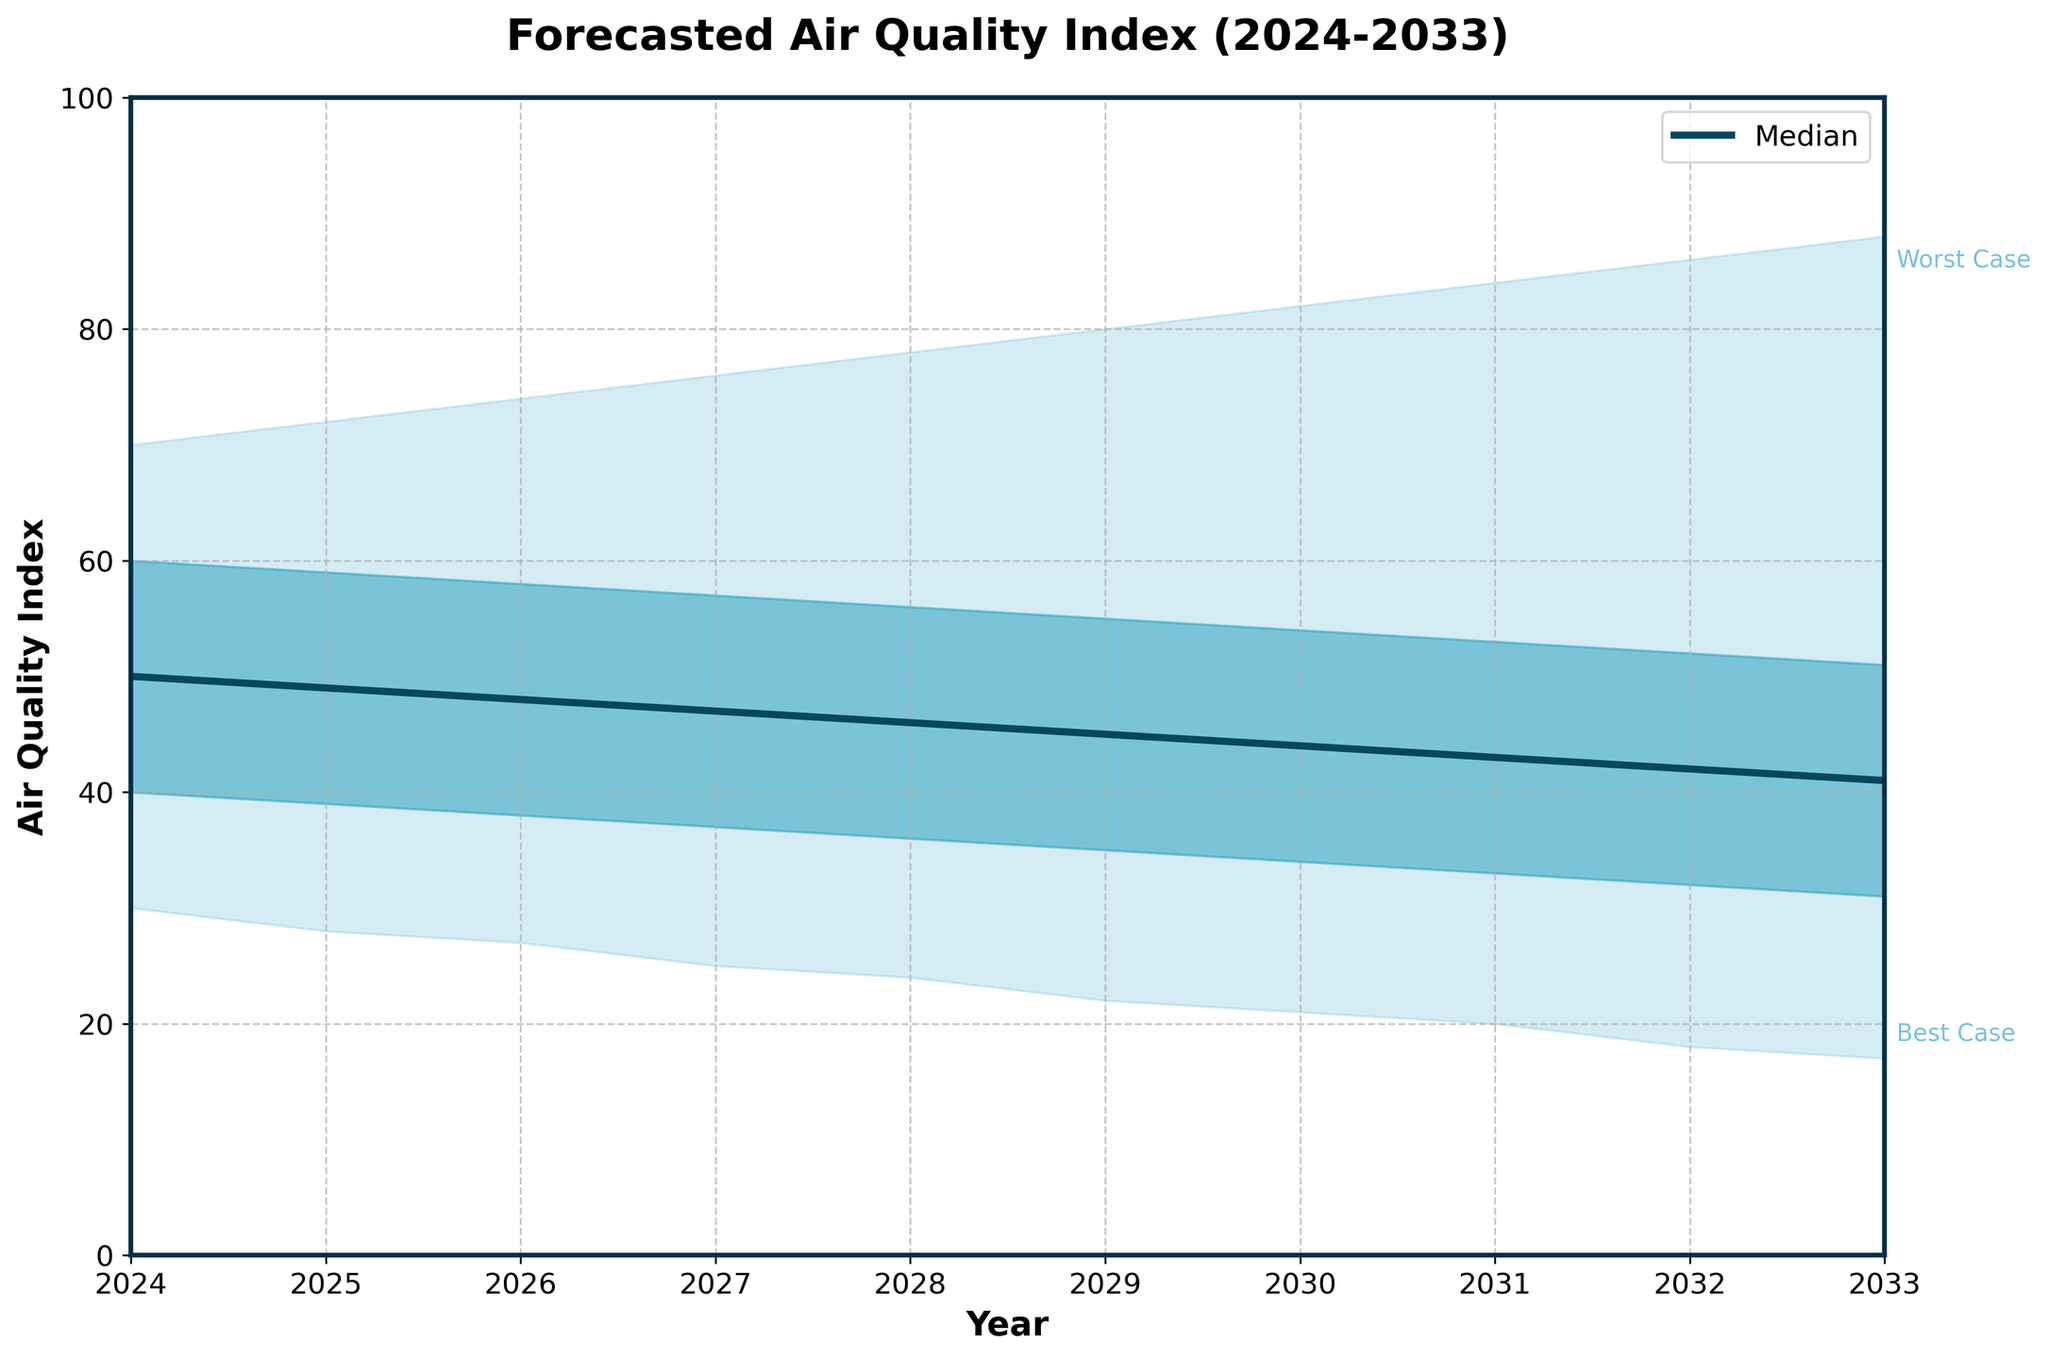What year has the lowest best-case air quality index (AQI)? First, identify the "Best Case" line from the figure. Then, trace it to the year where it reaches its lowest point.
Answer: 2033 What is the median AQI forecast for 2028? Find the median line in the chart, then locate 2028 on the x-axis and read the corresponding AQI value.
Answer: 46 Which year has the highest worst-case AQI forecast? Identify the "Worst Case" line and follow it to the year where it peaks.
Answer: 2033 How does the AQI's worst-case scenario in 2030 compare to the median AQI in the same year? Locate 2030 on both the "Worst Case" and "Median" lines. Compare the values of the two points.
Answer: The worst-case is 82, the median is 44 What is the range of AQI values in 2027? Calculate the difference between the worst-case and best-case scenarios for 2027 by locating both values on the y-axis.
Answer: 51 (76 - 25) Which year has the smallest interquartile range (difference between the upper and lower quartiles)? Calculate or read the difference between the lower and upper quartiles for each year, then identify the smallest difference.
Answer: 2024 (20) What trend do you observe in the best-case AQI scenario from 2024 to 2033? Look at how the "Best Case" line moves over the years, noting if it increases, decreases, or remains stable.
Answer: Decreasing trend What is the difference in the upper quartile AQI between 2024 and 2033? Identify the upper quartile values for the years 2024 and 2033, then subtract the 2024 value from the 2033 value.
Answer: 20 (51 - 71) In which year is the median AQI forecasted to be the highest? Trace the median line and identify the year with the highest AQI value.
Answer: 2024 What is the AQI range between the lower and upper quartiles for 2029? Find the values at the lower and upper quartiles for 2029 and subtract the lower value from the upper value.
Answer: 20 (55 - 35) 